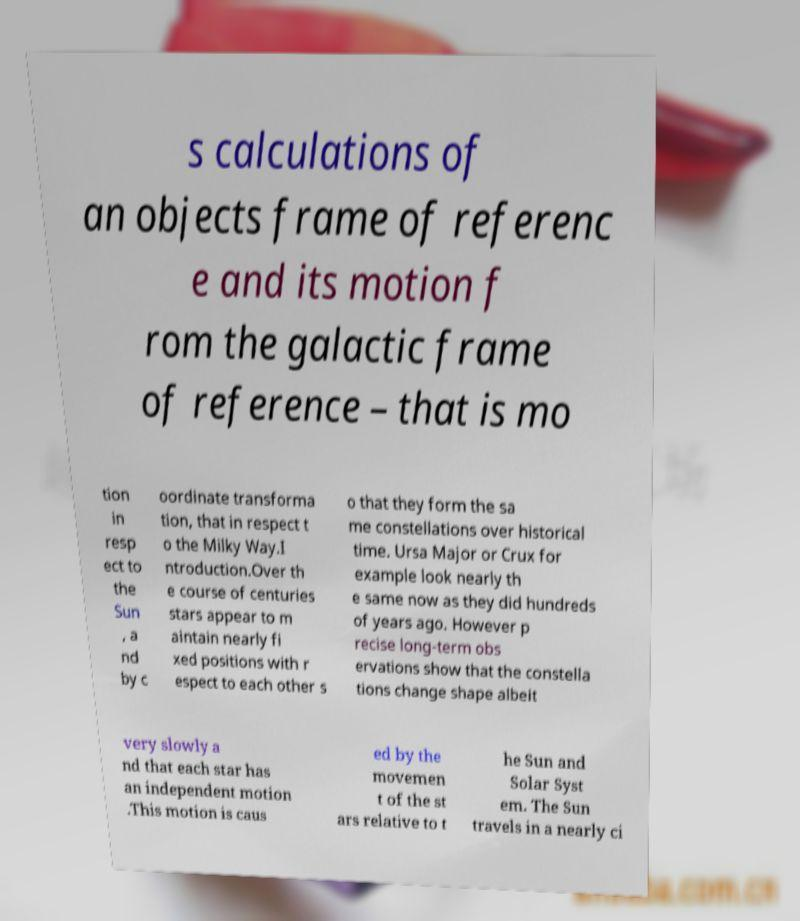Please read and relay the text visible in this image. What does it say? s calculations of an objects frame of referenc e and its motion f rom the galactic frame of reference – that is mo tion in resp ect to the Sun , a nd by c oordinate transforma tion, that in respect t o the Milky Way.I ntroduction.Over th e course of centuries stars appear to m aintain nearly fi xed positions with r espect to each other s o that they form the sa me constellations over historical time. Ursa Major or Crux for example look nearly th e same now as they did hundreds of years ago. However p recise long-term obs ervations show that the constella tions change shape albeit very slowly a nd that each star has an independent motion .This motion is caus ed by the movemen t of the st ars relative to t he Sun and Solar Syst em. The Sun travels in a nearly ci 